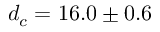<formula> <loc_0><loc_0><loc_500><loc_500>d _ { c } = 1 6 . 0 \pm 0 . 6</formula> 